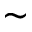<formula> <loc_0><loc_0><loc_500><loc_500>\sim</formula> 